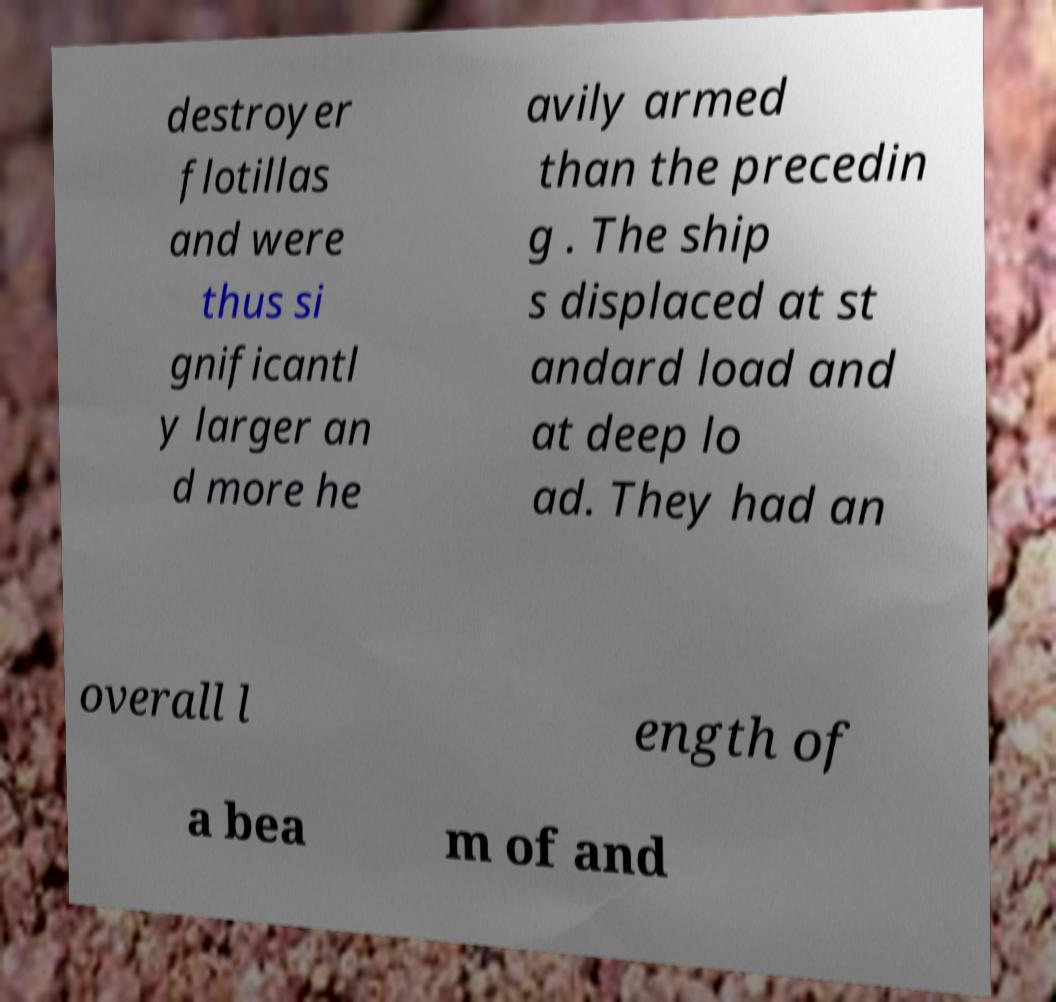Can you accurately transcribe the text from the provided image for me? destroyer flotillas and were thus si gnificantl y larger an d more he avily armed than the precedin g . The ship s displaced at st andard load and at deep lo ad. They had an overall l ength of a bea m of and 